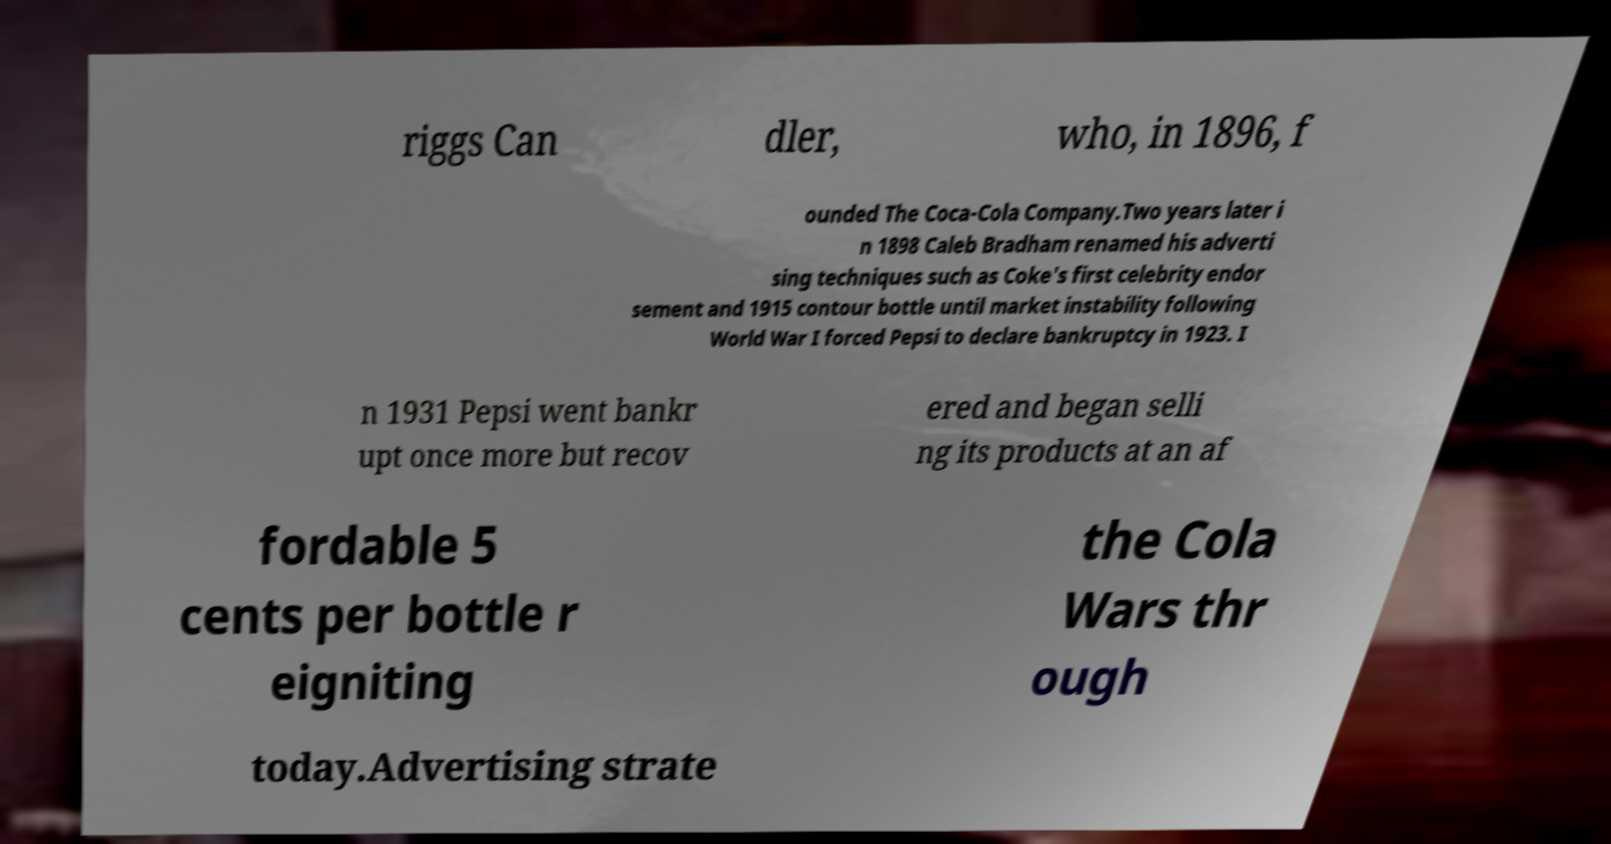Could you assist in decoding the text presented in this image and type it out clearly? riggs Can dler, who, in 1896, f ounded The Coca-Cola Company.Two years later i n 1898 Caleb Bradham renamed his adverti sing techniques such as Coke's first celebrity endor sement and 1915 contour bottle until market instability following World War I forced Pepsi to declare bankruptcy in 1923. I n 1931 Pepsi went bankr upt once more but recov ered and began selli ng its products at an af fordable 5 cents per bottle r eigniting the Cola Wars thr ough today.Advertising strate 